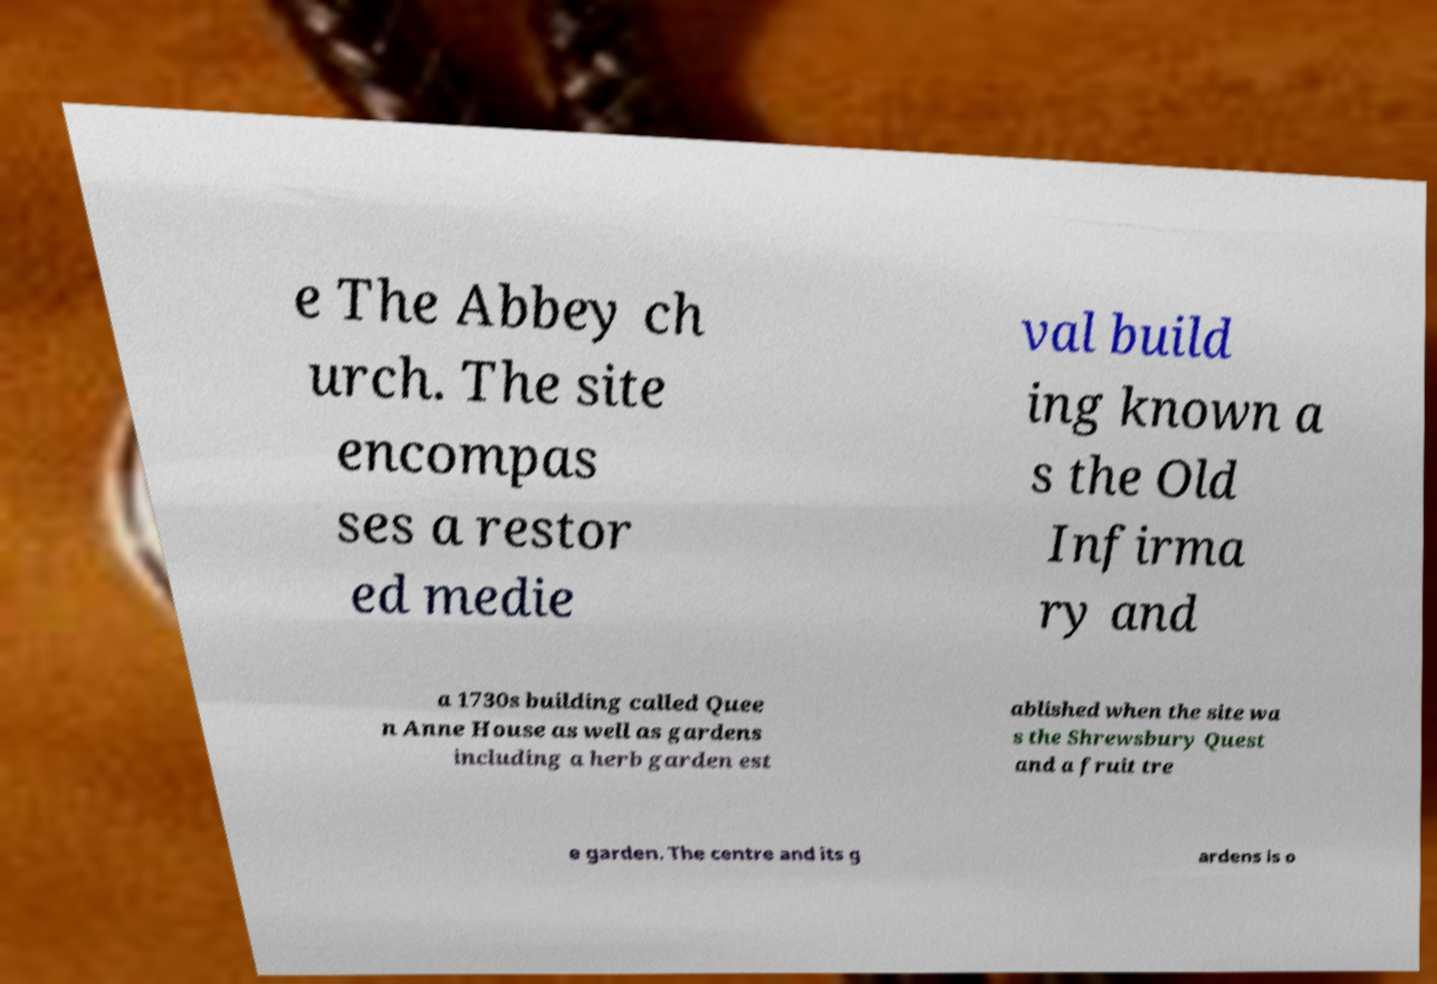For documentation purposes, I need the text within this image transcribed. Could you provide that? e The Abbey ch urch. The site encompas ses a restor ed medie val build ing known a s the Old Infirma ry and a 1730s building called Quee n Anne House as well as gardens including a herb garden est ablished when the site wa s the Shrewsbury Quest and a fruit tre e garden. The centre and its g ardens is o 